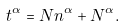Convert formula to latex. <formula><loc_0><loc_0><loc_500><loc_500>t ^ { \alpha } = N n ^ { \alpha } + N ^ { \alpha } .</formula> 